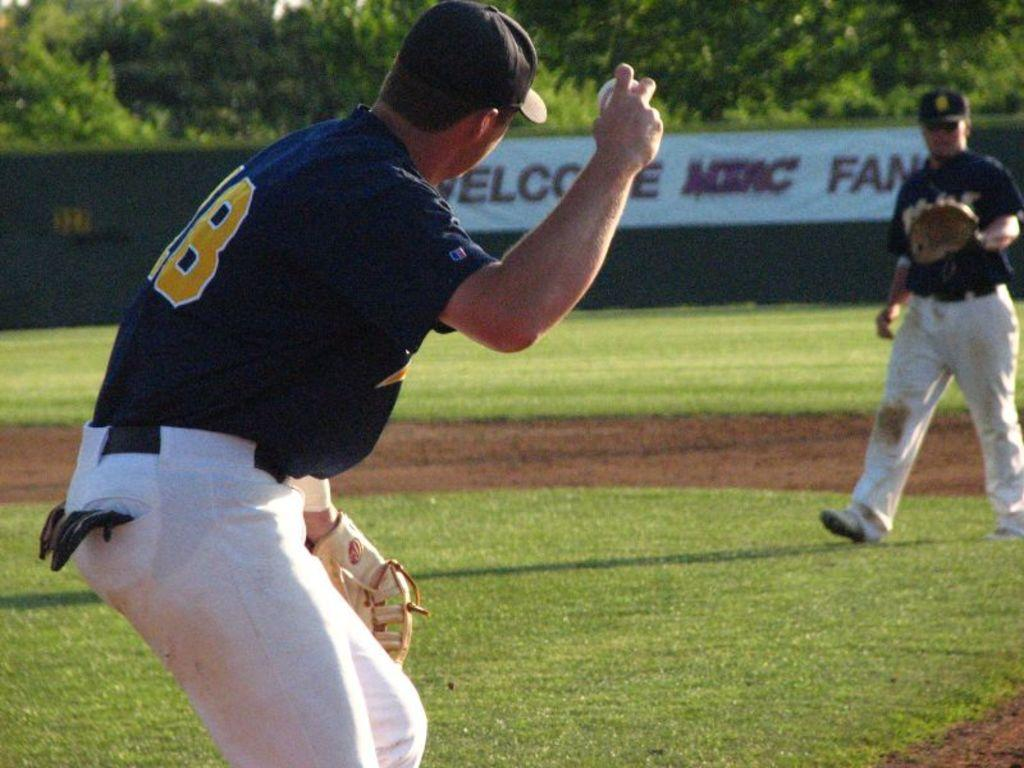<image>
Relay a brief, clear account of the picture shown. the man holding the baseball is wearing a jersey with number ending 8 